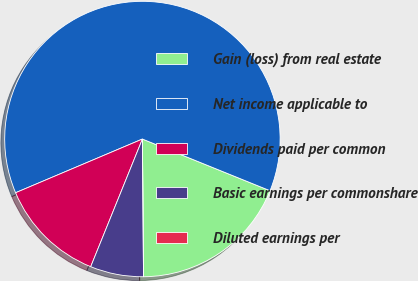Convert chart to OTSL. <chart><loc_0><loc_0><loc_500><loc_500><pie_chart><fcel>Gain (loss) from real estate<fcel>Net income applicable to<fcel>Dividends paid per common<fcel>Basic earnings per commonshare<fcel>Diluted earnings per<nl><fcel>18.75%<fcel>62.5%<fcel>12.5%<fcel>6.25%<fcel>0.0%<nl></chart> 